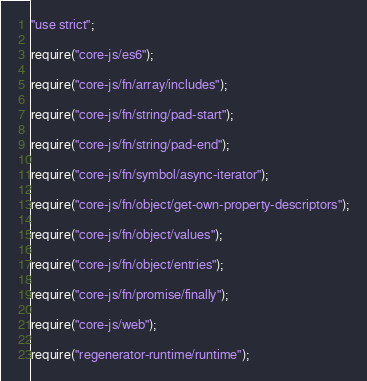<code> <loc_0><loc_0><loc_500><loc_500><_JavaScript_>"use strict";

require("core-js/es6");

require("core-js/fn/array/includes");

require("core-js/fn/string/pad-start");

require("core-js/fn/string/pad-end");

require("core-js/fn/symbol/async-iterator");

require("core-js/fn/object/get-own-property-descriptors");

require("core-js/fn/object/values");

require("core-js/fn/object/entries");

require("core-js/fn/promise/finally");

require("core-js/web");

require("regenerator-runtime/runtime");</code> 